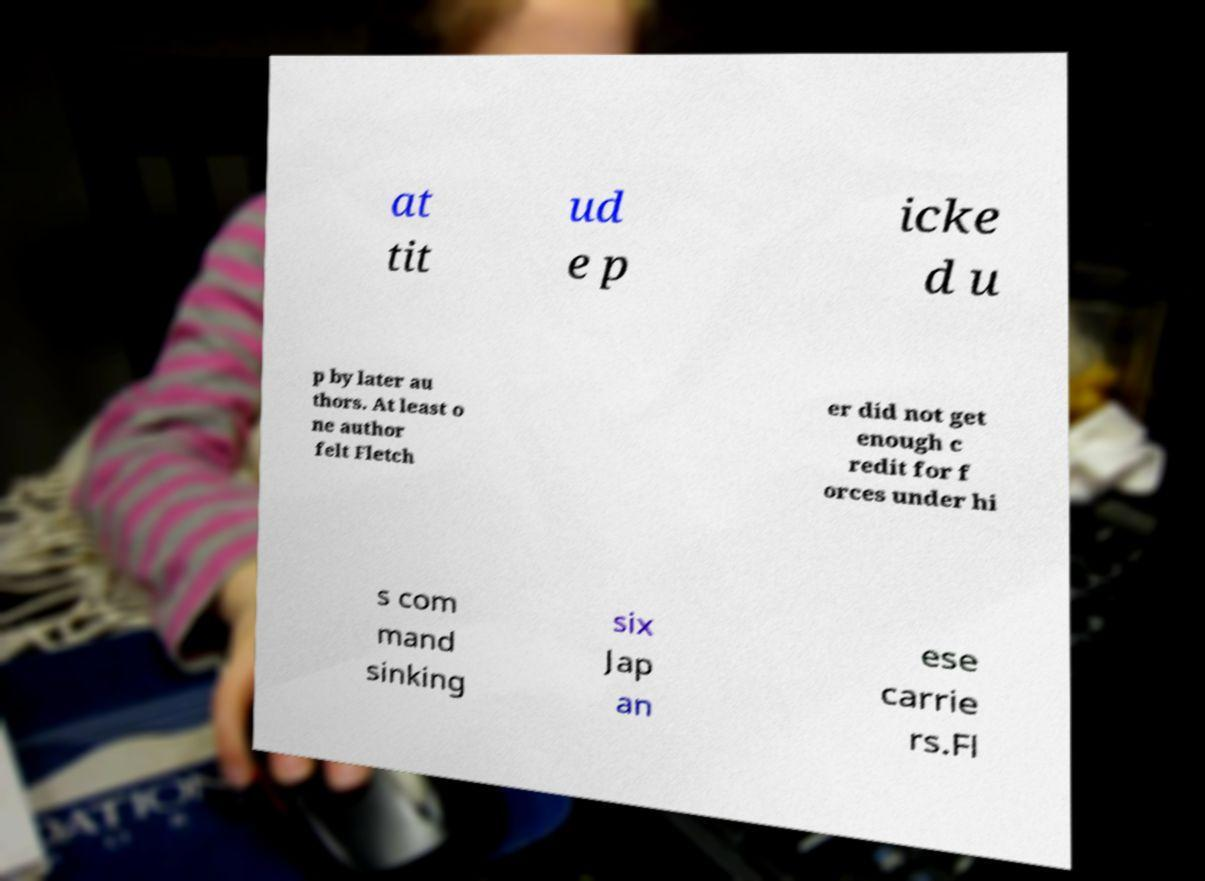Could you assist in decoding the text presented in this image and type it out clearly? at tit ud e p icke d u p by later au thors. At least o ne author felt Fletch er did not get enough c redit for f orces under hi s com mand sinking six Jap an ese carrie rs.Fl 